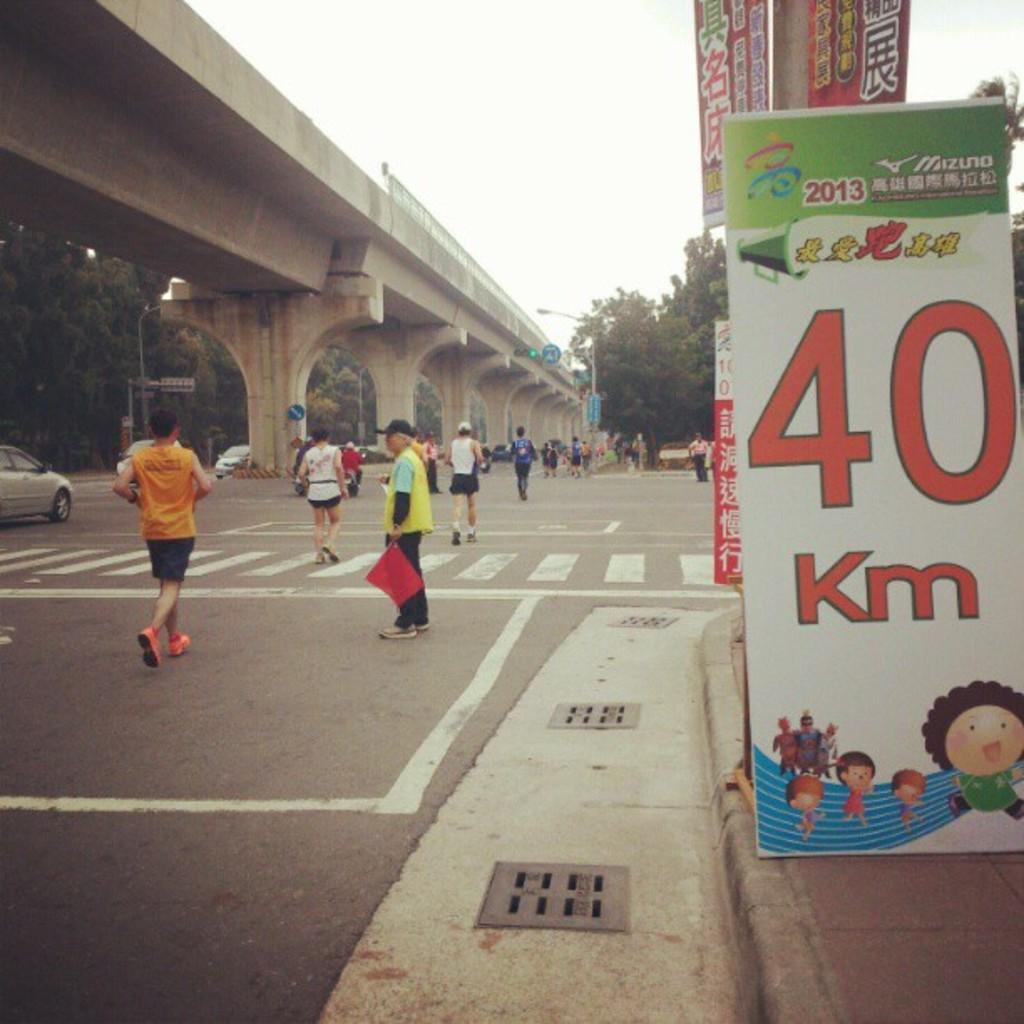What can be seen in the image? There are people, boards, a flyover, pillars, vehicles on the road, a traffic signal, poles, trees, and sky visible in the background. What type of structure is present in the image? There is a flyover in the image. What might be used to control traffic in the image? There is a traffic signal in the image. What can be seen in the background of the image? There are trees and sky visible in the background. What type of care is being provided to the trees in the image? There is no indication in the image that any care is being provided to the trees. What request can be seen being made by the people in the image? There is no indication in the image that any requests are being made by the people. 